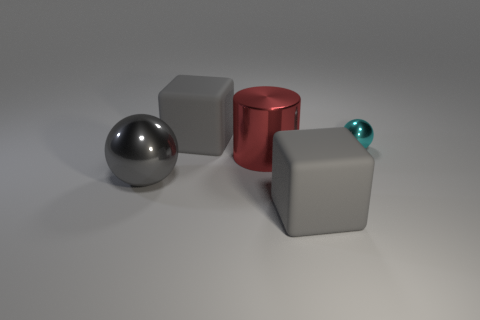Add 2 cubes. How many objects exist? 7 Subtract all balls. How many objects are left? 3 Add 1 metal objects. How many metal objects exist? 4 Subtract 0 green spheres. How many objects are left? 5 Subtract all large cyan blocks. Subtract all large rubber things. How many objects are left? 3 Add 3 large cubes. How many large cubes are left? 5 